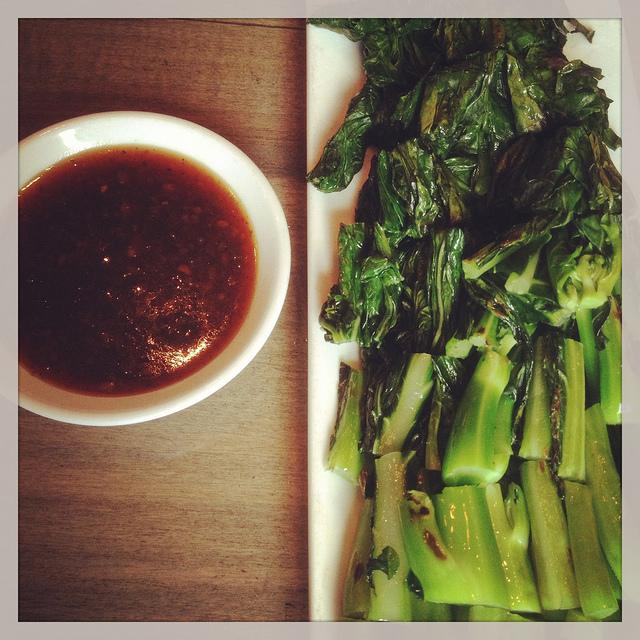What is about to be dipped? vegetables 